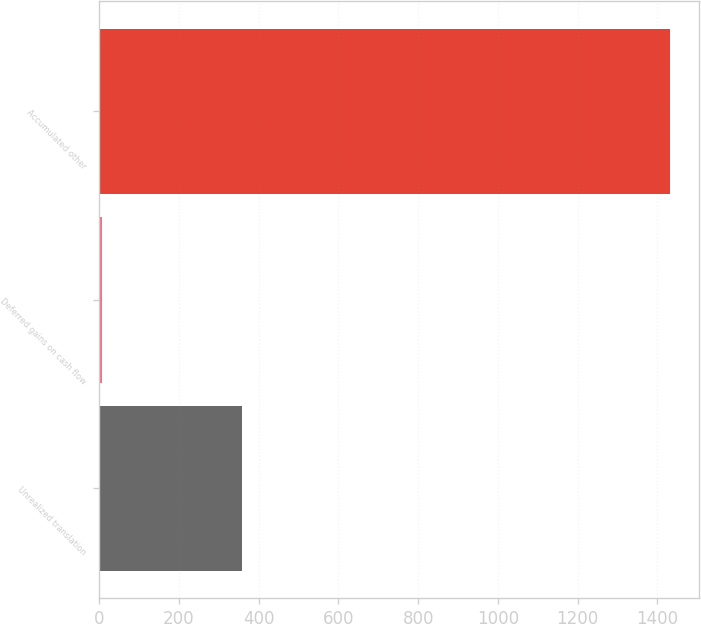Convert chart to OTSL. <chart><loc_0><loc_0><loc_500><loc_500><bar_chart><fcel>Unrealized translation<fcel>Deferred gains on cash flow<fcel>Accumulated other<nl><fcel>358.2<fcel>6.1<fcel>1432.2<nl></chart> 